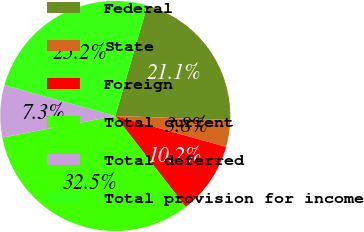Convert chart. <chart><loc_0><loc_0><loc_500><loc_500><pie_chart><fcel>Federal<fcel>State<fcel>Foreign<fcel>Total current<fcel>Total deferred<fcel>Total provision for income<nl><fcel>21.06%<fcel>3.77%<fcel>10.18%<fcel>32.49%<fcel>7.31%<fcel>25.18%<nl></chart> 